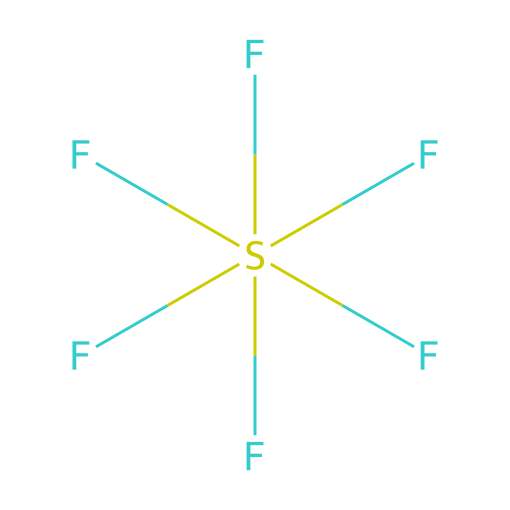How many fluorine atoms are present in the molecule? The SMILES representation indicates six fluorine atoms attached to the sulfur atom (F[S](F)(F)(F)(F)F). Each 'F' in the notation corresponds to a fluorine atom.
Answer: six What is the central atom in this compound? The central atom in this SMILES representation is denoted by 'S', which corresponds to sulfur, the atom that connects all fluorine atoms.
Answer: sulfur How many total atoms are in sulfur hexafluoride? This molecule consists of one sulfur atom and six fluorine atoms, totaling seven atoms as calculated (1 sulfur + 6 fluorine = 7).
Answer: seven What type of bonds are primarily present in this chemical? The bonds between sulfur and fluorine in this compound are covalent bonds, as evidenced by the direct association of atoms shown in the SMILES notation.
Answer: covalent Why is sulfur hexafluoride used in high-voltage applications? Sulfur hexafluoride has excellent electrical insulating properties due to its high electronegativity and molecular stability, making it suitable for high-voltage circuit breakers.
Answer: electrical insulator What is the molecular formula for sulfur hexafluoride? The molecular formula is determined from the SMILES representation where there are one sulfur atom and six fluorine atoms, represented as SF6.
Answer: SF6 